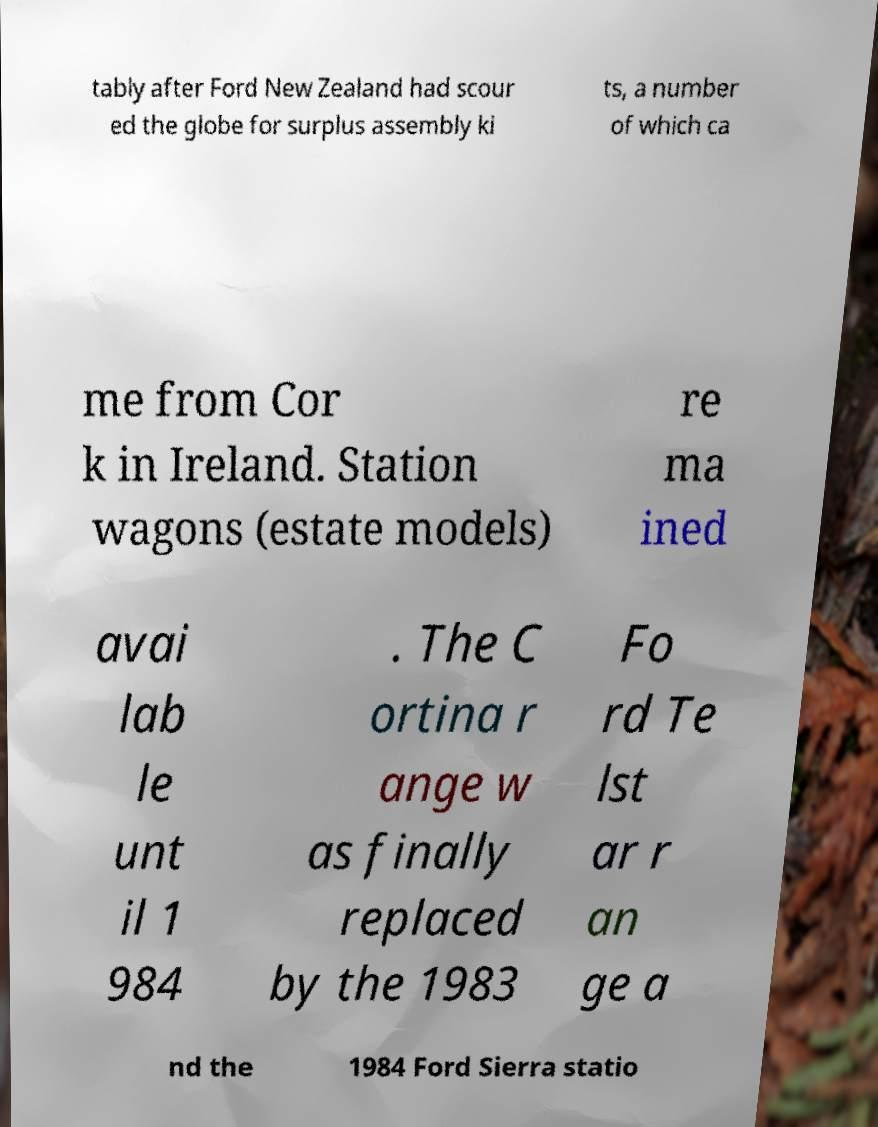Please identify and transcribe the text found in this image. tably after Ford New Zealand had scour ed the globe for surplus assembly ki ts, a number of which ca me from Cor k in Ireland. Station wagons (estate models) re ma ined avai lab le unt il 1 984 . The C ortina r ange w as finally replaced by the 1983 Fo rd Te lst ar r an ge a nd the 1984 Ford Sierra statio 